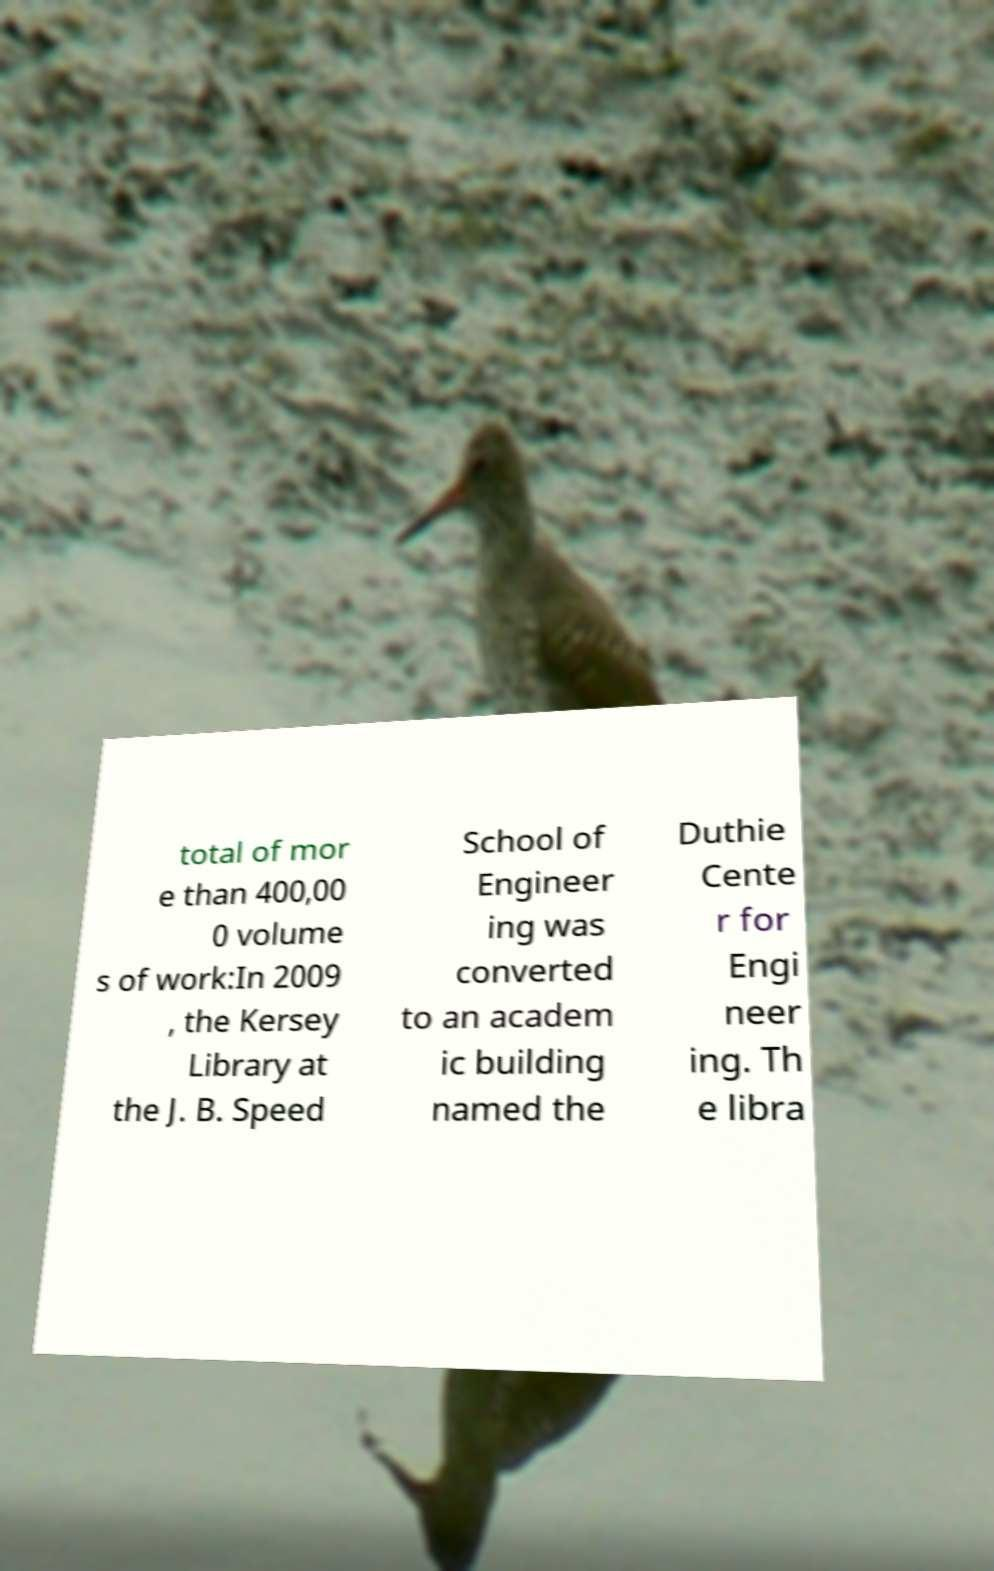Can you read and provide the text displayed in the image?This photo seems to have some interesting text. Can you extract and type it out for me? total of mor e than 400,00 0 volume s of work:In 2009 , the Kersey Library at the J. B. Speed School of Engineer ing was converted to an academ ic building named the Duthie Cente r for Engi neer ing. Th e libra 